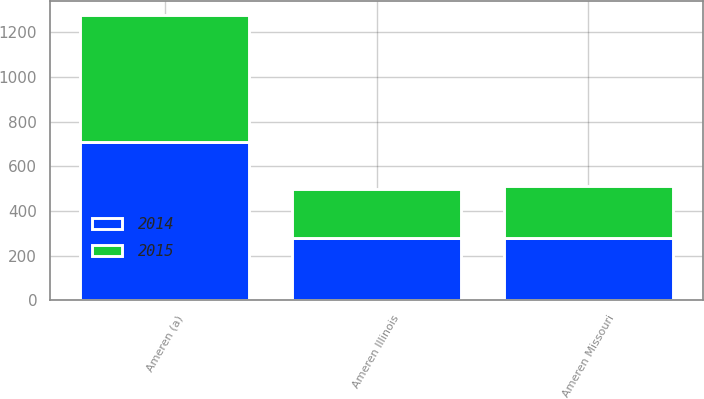Convert chart to OTSL. <chart><loc_0><loc_0><loc_500><loc_500><stacked_bar_chart><ecel><fcel>Ameren (a)<fcel>Ameren Missouri<fcel>Ameren Illinois<nl><fcel>2015<fcel>567<fcel>236<fcel>219<nl><fcel>2014<fcel>710<fcel>277<fcel>278<nl></chart> 